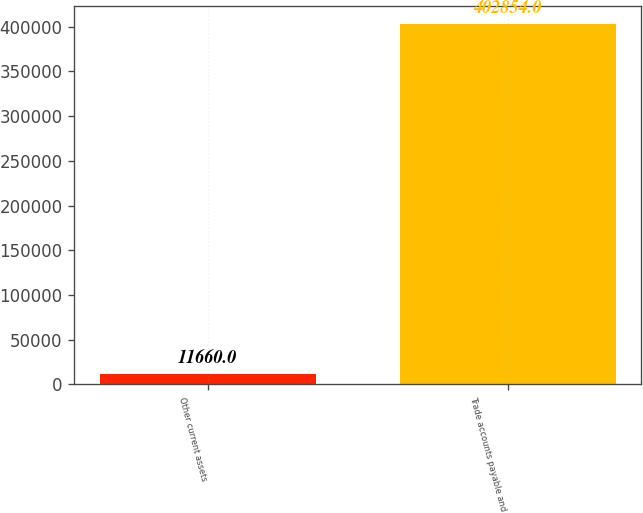<chart> <loc_0><loc_0><loc_500><loc_500><bar_chart><fcel>Other current assets<fcel>Trade accounts payable and<nl><fcel>11660<fcel>402854<nl></chart> 